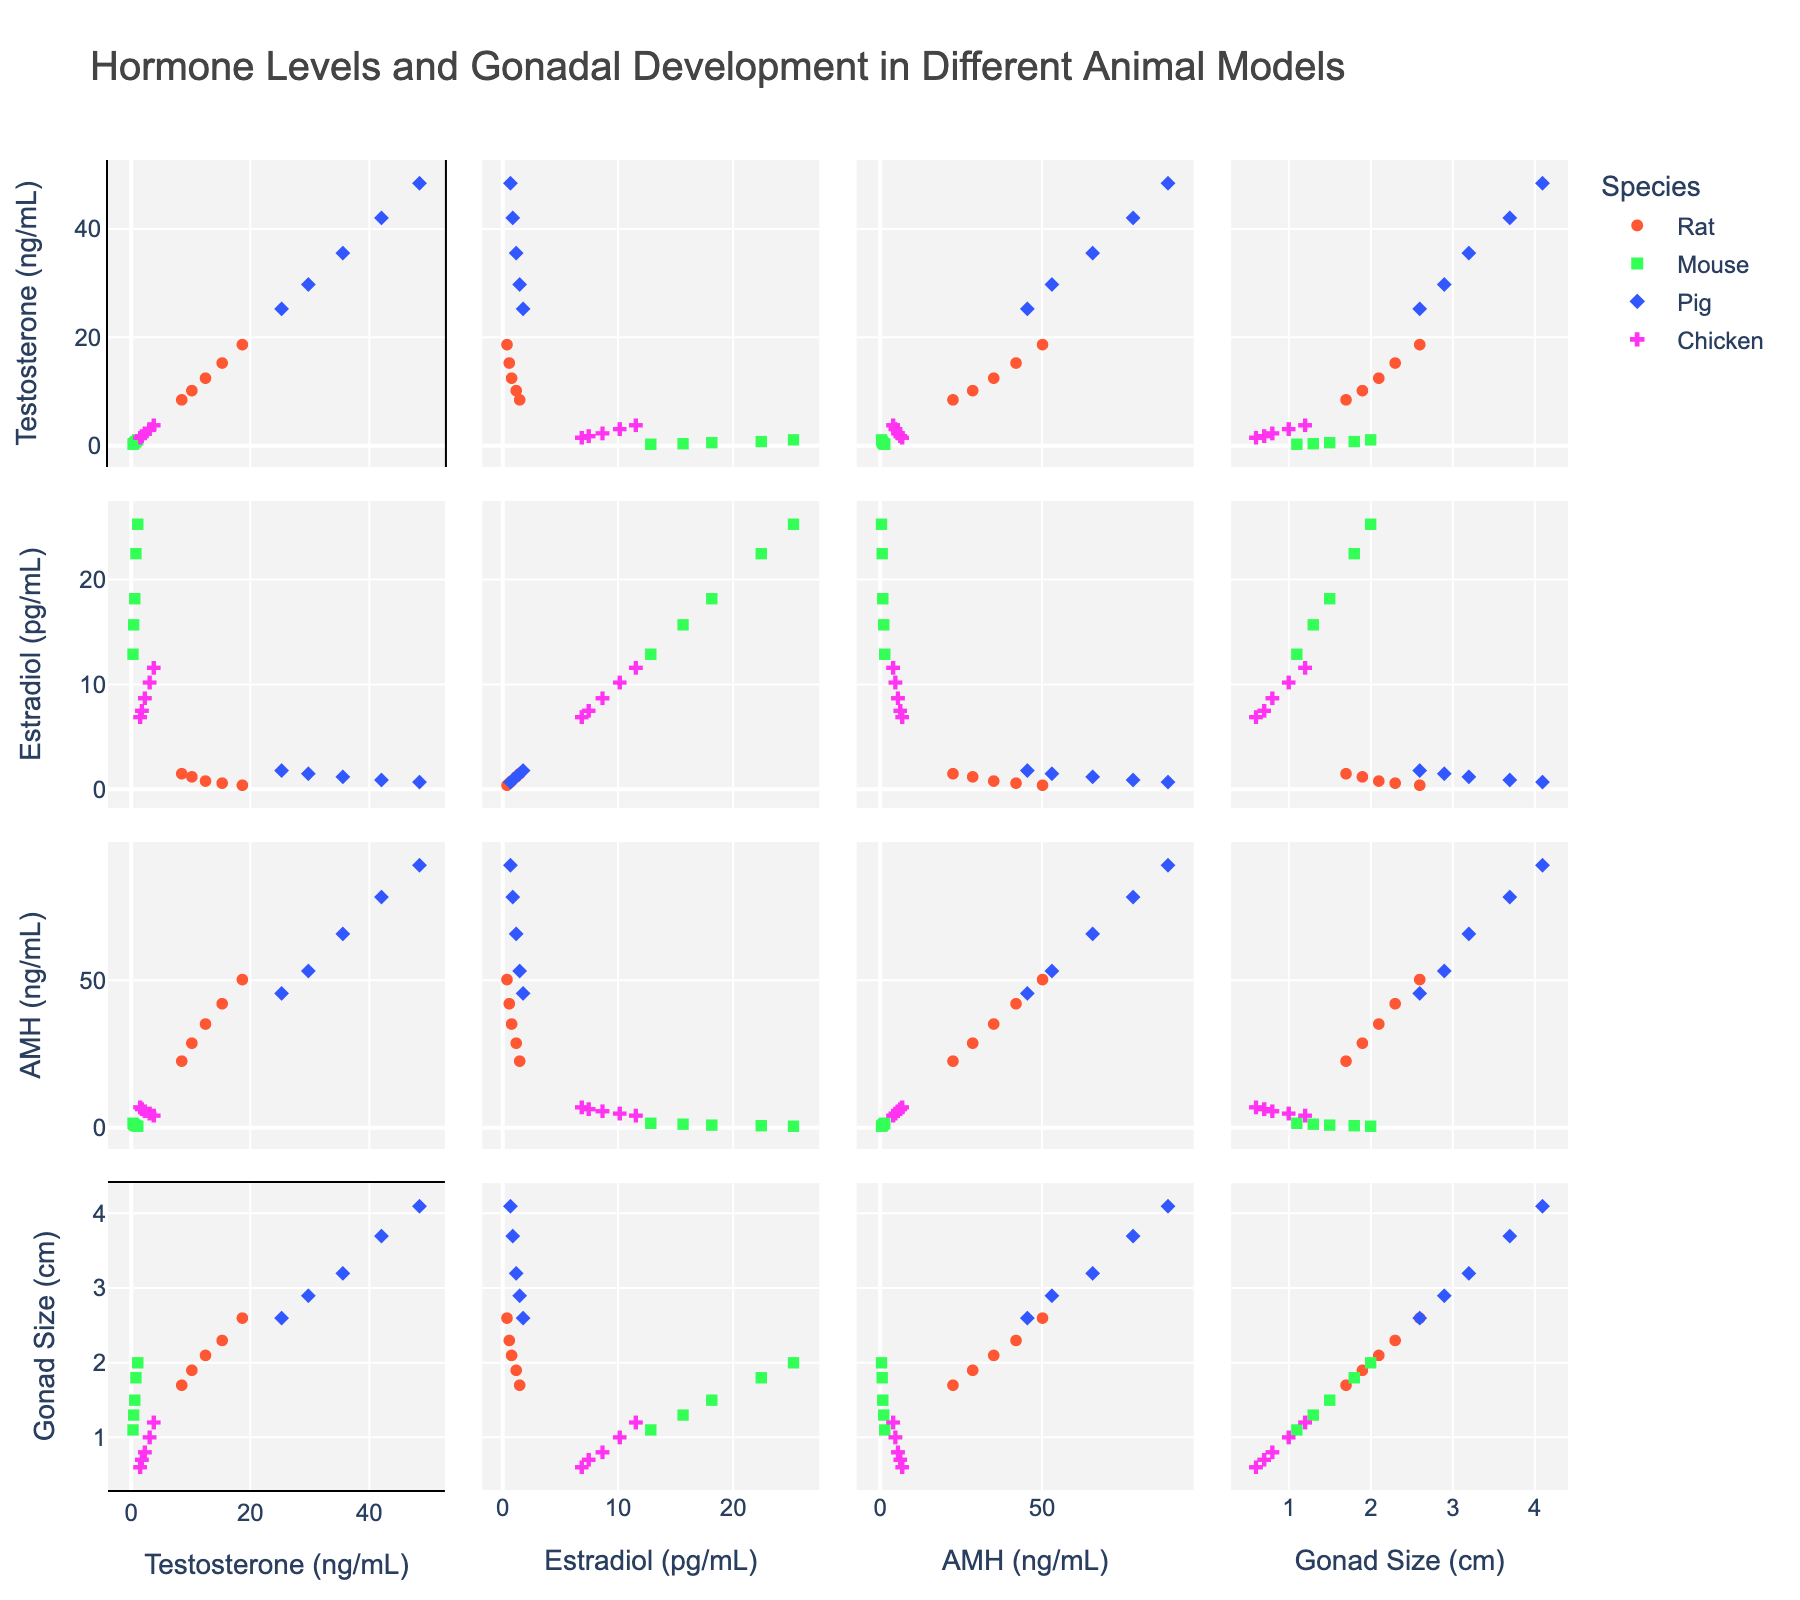what is the title of the figure? The title is displayed at the top of the figure.
Answer: Hormone Levels and Gonadal Development in Different Animal Models how many species are represented in the figure? The species are differentiated by color and symbol as indicated in the legend, which lists the different species.
Answer: Four which species is represented by the diamond symbol in the figure? The legend shows which species correspond to each symbol, with the diamond symbol specifically assigned to one species.
Answer: Pig among the species, which has the highest testosterone levels? By examining the scatter points along the Testosterone axis, the species with the highest values can be identified.
Answer: Pig how does gonad size correlate with estradiol levels in mice? The scatter points for mice can be isolated by color and symbol, and the relationship between the Gonad_Size and Estradiol axes can be observed.
Answer: Positively correlated which species shows the widest range of AMH levels? The range of AMH levels can be determined by comparing the spread of points along the AMH axis for each species.
Answer: Pig what is the average gonad size for chickens? Identify all the data points for chickens (cross symbol and specified color) and calculate the arithmetic mean of their Gonad_Size values.
Answer: 0.86 cm do rats or chickens have higher estradiol levels on average? Calculate the average Estradiol levels for rats and chickens separately by averaging the points corresponding to each species, then compare the two averages.
Answer: Chickens are there any species with no overlap in AMH levels with others? Examine the overlap of AMH levels across the species by looking at how the points for each species align on the AMH axis.
Answer: No do testosterone and gonad size show a direct relationship in pigs? Look at the scatter points for pigs (diamond symbol and specified color) and observe the trend between the Testosterone and Gonad_Size axes.
Answer: Yes 